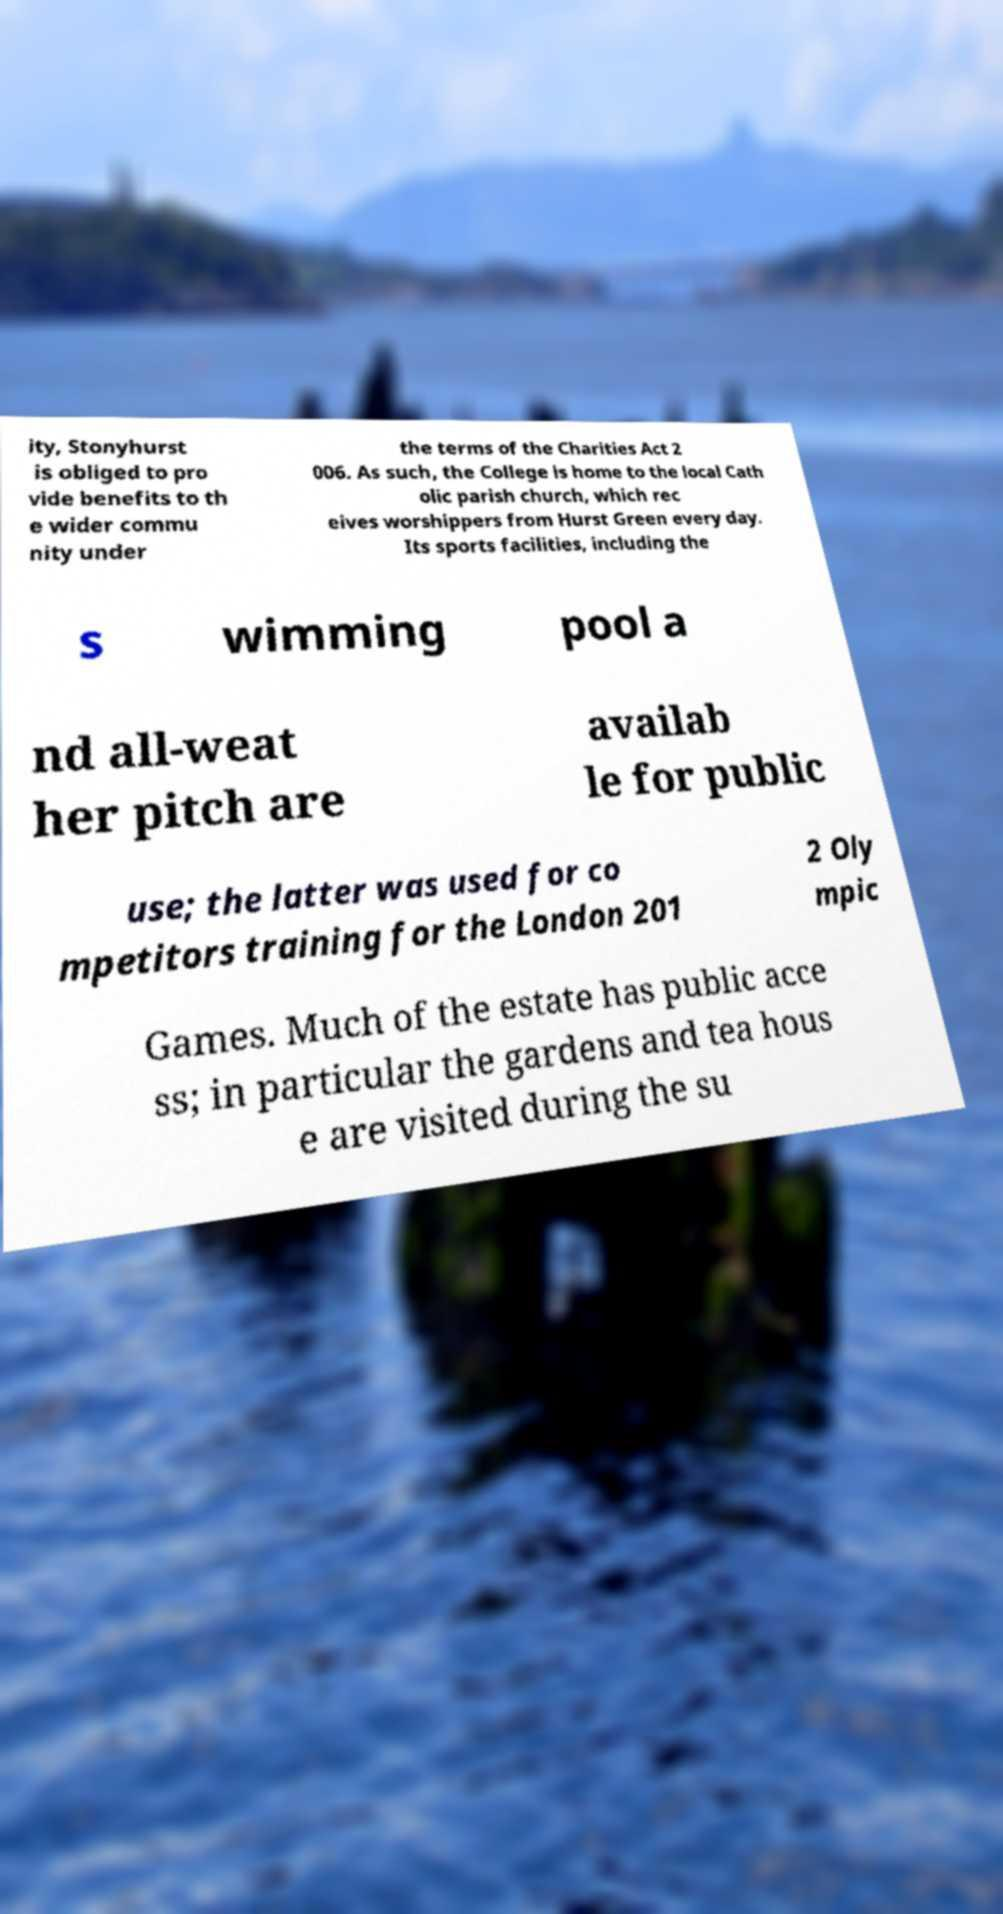Can you accurately transcribe the text from the provided image for me? ity, Stonyhurst is obliged to pro vide benefits to th e wider commu nity under the terms of the Charities Act 2 006. As such, the College is home to the local Cath olic parish church, which rec eives worshippers from Hurst Green every day. Its sports facilities, including the s wimming pool a nd all-weat her pitch are availab le for public use; the latter was used for co mpetitors training for the London 201 2 Oly mpic Games. Much of the estate has public acce ss; in particular the gardens and tea hous e are visited during the su 